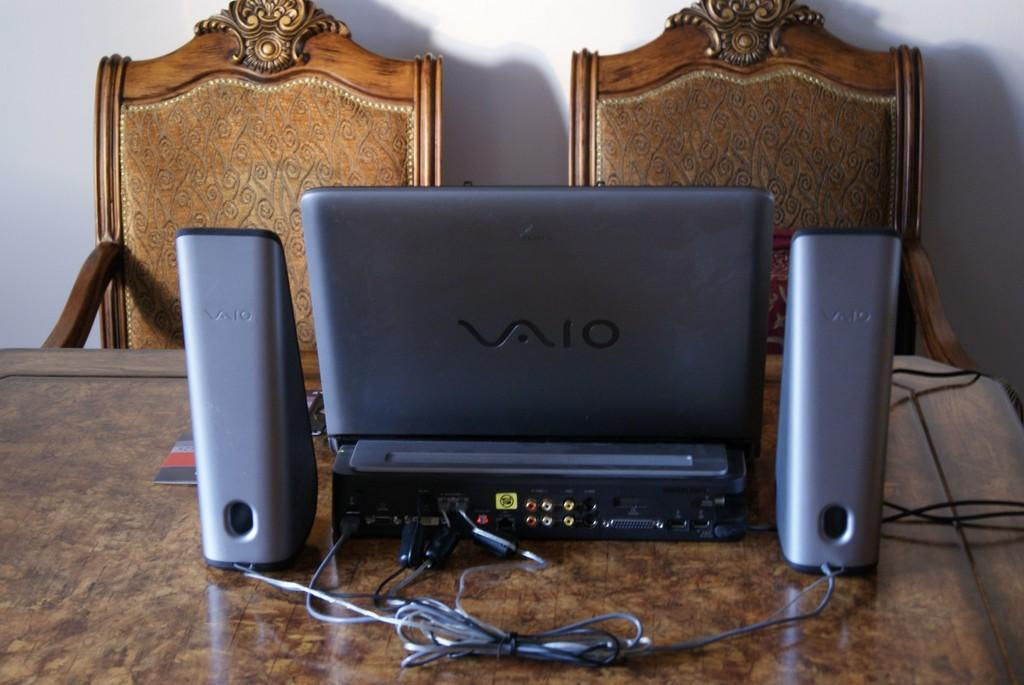What is the main piece of furniture in the image? There is a table in the image. What electronic devices are on the table? There are speakers and a laptop on the table. Are there any wires or cables visible on the table? Yes, there are cables on the table. What type of seating is behind the table? There are chairs behind the table. What can be seen in the background of the image? The sky is visible in the background of the image. What is your brother doing in the image? There is no brother present in the image. What force is causing the laptop to levitate in the image? The laptop is not levitating in the image; it is resting on the table. 